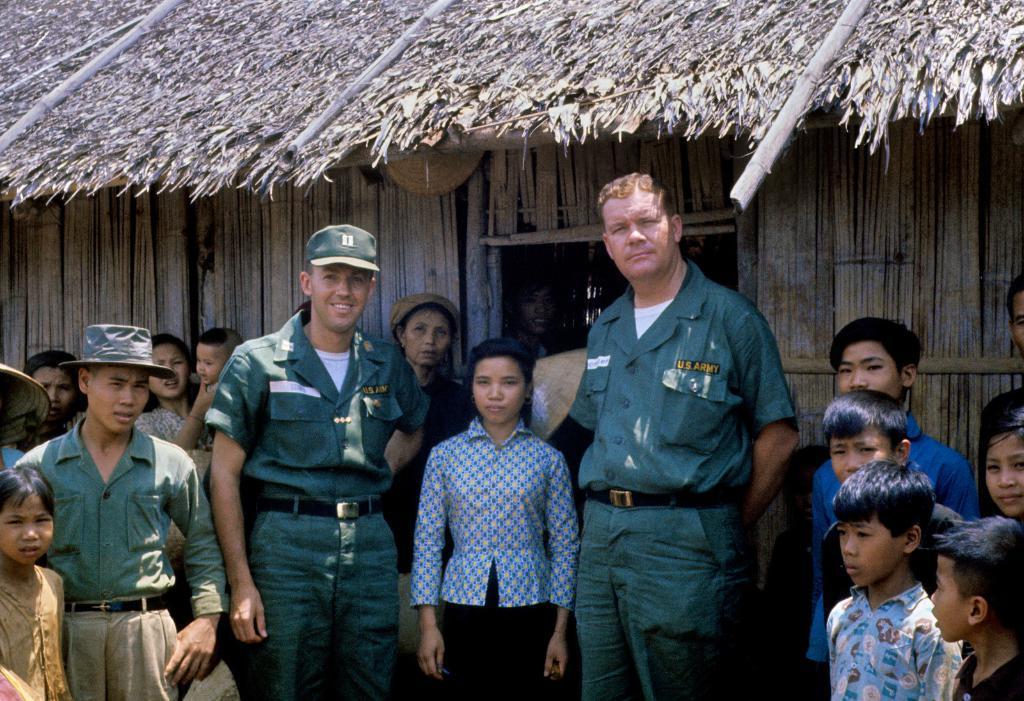Can you describe this image briefly? In the picture we can see a wooden house and the roof is covered with dried grass and bamboos and near to the house we can see some children and two men are standing with uniforms. 